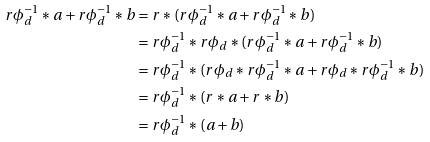Convert formula to latex. <formula><loc_0><loc_0><loc_500><loc_500>r \phi _ { d } ^ { - 1 } * a + r \phi _ { d } ^ { - 1 } * b & = r * ( r \phi _ { d } ^ { - 1 } * a + r \phi _ { d } ^ { - 1 } * b ) \\ & = r \phi _ { d } ^ { - 1 } * r \phi _ { d } * ( r \phi _ { d } ^ { - 1 } * a + r \phi _ { d } ^ { - 1 } * b ) \\ & = r \phi _ { d } ^ { - 1 } * ( r \phi _ { d } * r \phi _ { d } ^ { - 1 } * a + r \phi _ { d } * r \phi _ { d } ^ { - 1 } * b ) \\ & = r \phi _ { d } ^ { - 1 } * ( r * a + r * b ) \\ & = r \phi _ { d } ^ { - 1 } * ( a + b )</formula> 